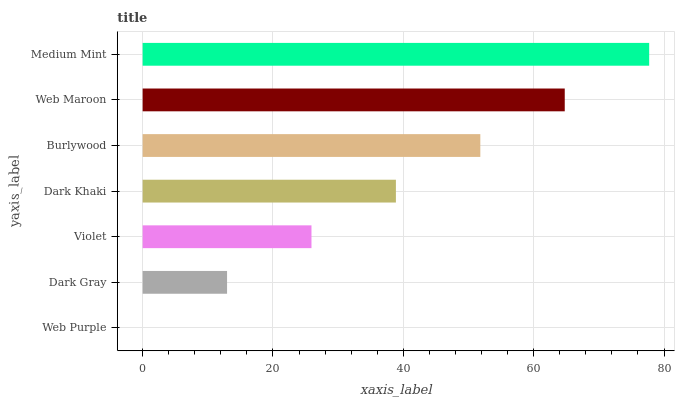Is Web Purple the minimum?
Answer yes or no. Yes. Is Medium Mint the maximum?
Answer yes or no. Yes. Is Dark Gray the minimum?
Answer yes or no. No. Is Dark Gray the maximum?
Answer yes or no. No. Is Dark Gray greater than Web Purple?
Answer yes or no. Yes. Is Web Purple less than Dark Gray?
Answer yes or no. Yes. Is Web Purple greater than Dark Gray?
Answer yes or no. No. Is Dark Gray less than Web Purple?
Answer yes or no. No. Is Dark Khaki the high median?
Answer yes or no. Yes. Is Dark Khaki the low median?
Answer yes or no. Yes. Is Dark Gray the high median?
Answer yes or no. No. Is Medium Mint the low median?
Answer yes or no. No. 